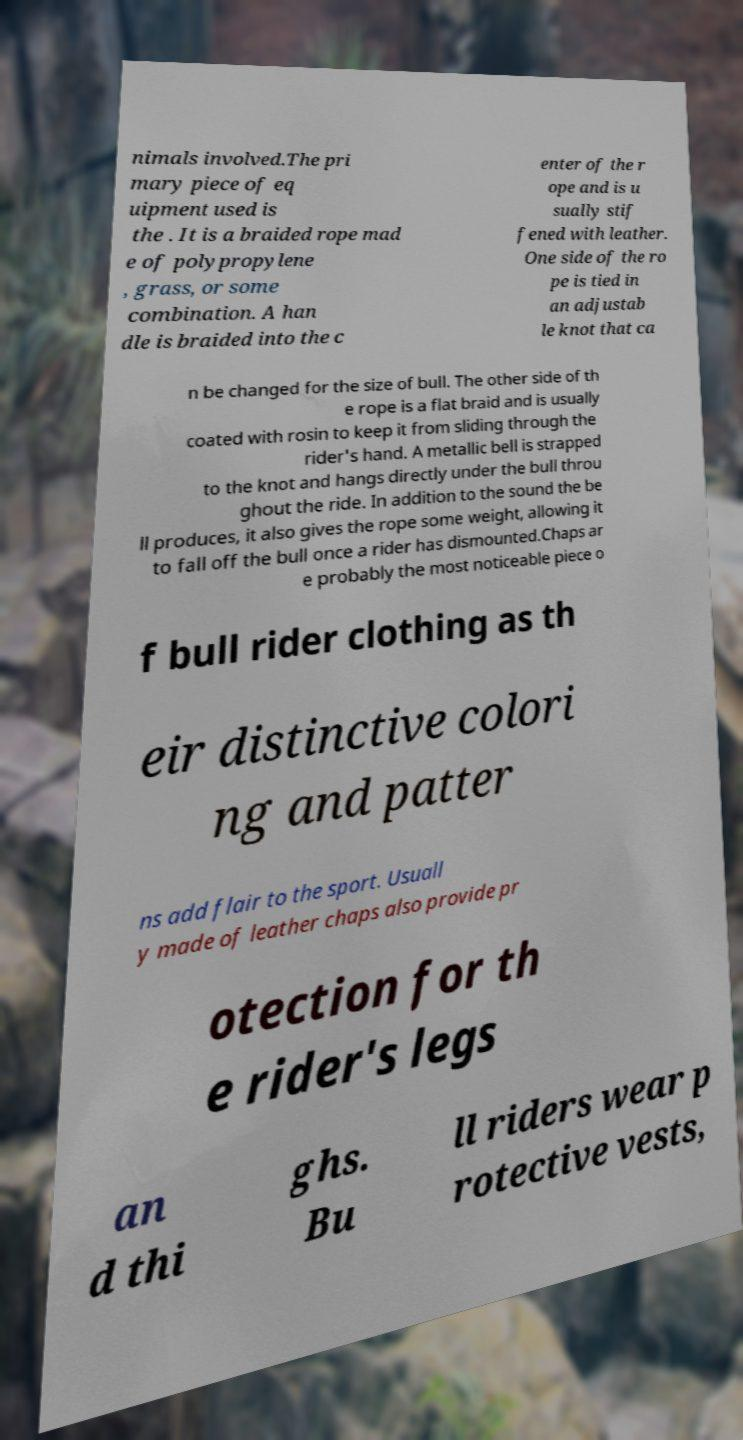Please read and relay the text visible in this image. What does it say? nimals involved.The pri mary piece of eq uipment used is the . It is a braided rope mad e of polypropylene , grass, or some combination. A han dle is braided into the c enter of the r ope and is u sually stif fened with leather. One side of the ro pe is tied in an adjustab le knot that ca n be changed for the size of bull. The other side of th e rope is a flat braid and is usually coated with rosin to keep it from sliding through the rider's hand. A metallic bell is strapped to the knot and hangs directly under the bull throu ghout the ride. In addition to the sound the be ll produces, it also gives the rope some weight, allowing it to fall off the bull once a rider has dismounted.Chaps ar e probably the most noticeable piece o f bull rider clothing as th eir distinctive colori ng and patter ns add flair to the sport. Usuall y made of leather chaps also provide pr otection for th e rider's legs an d thi ghs. Bu ll riders wear p rotective vests, 